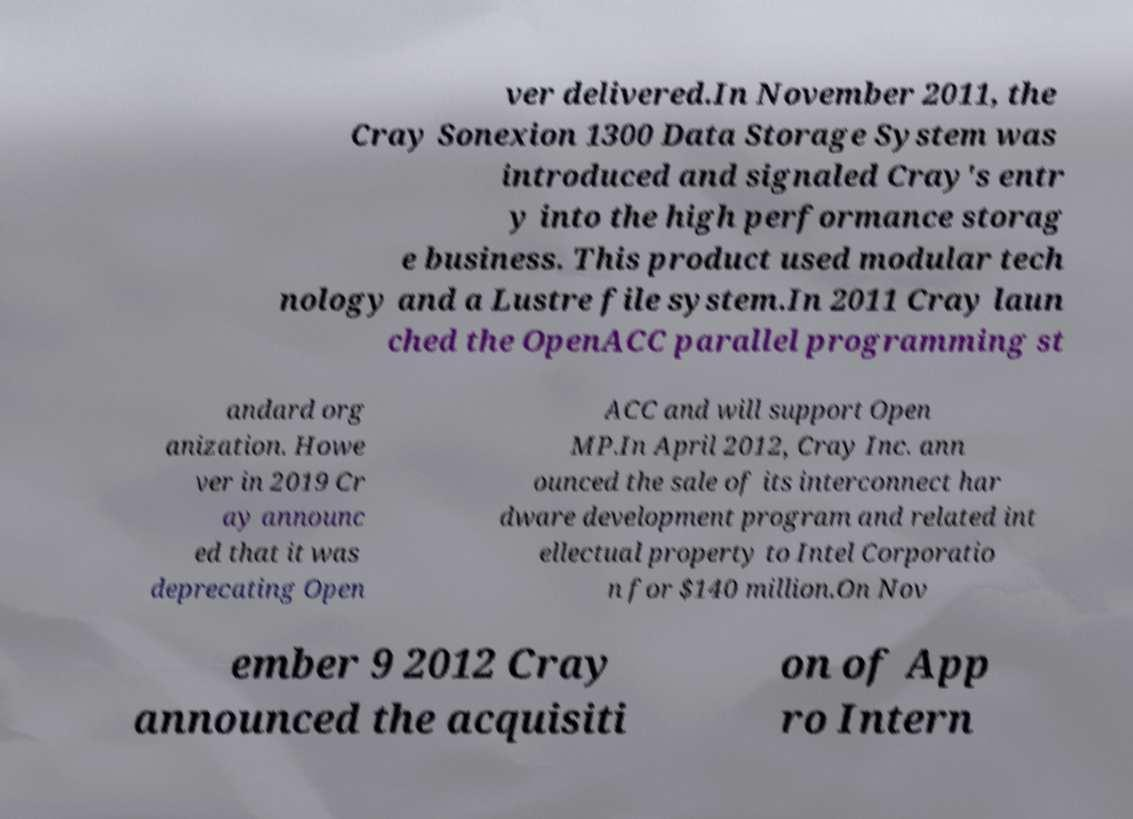Please identify and transcribe the text found in this image. ver delivered.In November 2011, the Cray Sonexion 1300 Data Storage System was introduced and signaled Cray's entr y into the high performance storag e business. This product used modular tech nology and a Lustre file system.In 2011 Cray laun ched the OpenACC parallel programming st andard org anization. Howe ver in 2019 Cr ay announc ed that it was deprecating Open ACC and will support Open MP.In April 2012, Cray Inc. ann ounced the sale of its interconnect har dware development program and related int ellectual property to Intel Corporatio n for $140 million.On Nov ember 9 2012 Cray announced the acquisiti on of App ro Intern 